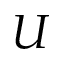Convert formula to latex. <formula><loc_0><loc_0><loc_500><loc_500>U</formula> 